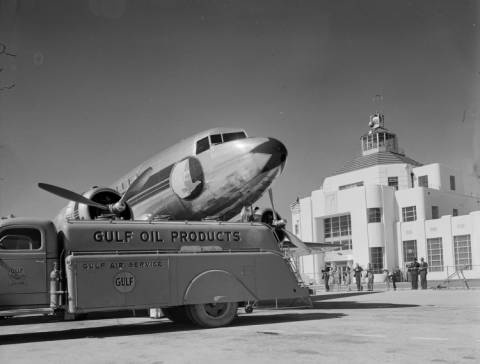Describe the objects in this image and their specific colors. I can see truck in black, gray, and lightgray tones, airplane in black, darkgray, gray, and lightgray tones, people in black and gray tones, people in gray, black, and darkgray tones, and people in black, gray, darkgray, and lightgray tones in this image. 